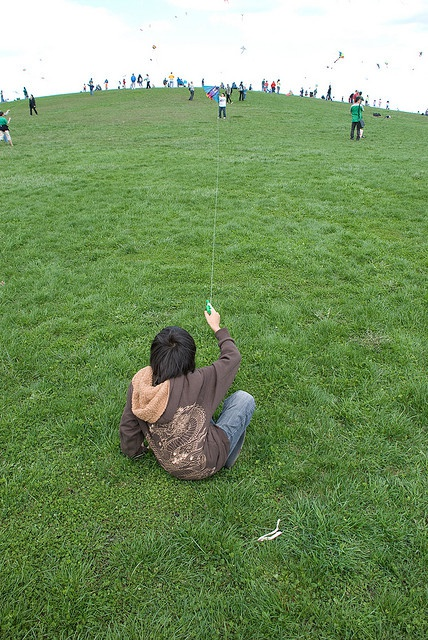Describe the objects in this image and their specific colors. I can see people in white, gray, black, and darkgray tones, people in white, green, olive, and darkgray tones, people in white, black, teal, and gray tones, people in white, lightgray, black, green, and darkgray tones, and kite in white and lightblue tones in this image. 